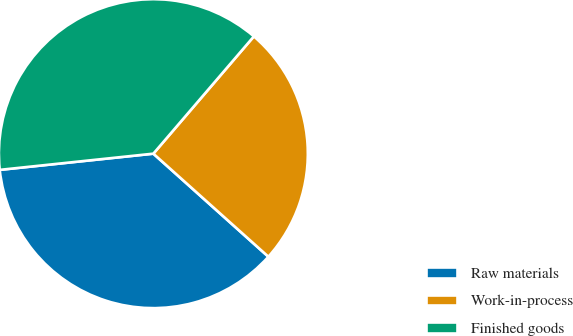Convert chart to OTSL. <chart><loc_0><loc_0><loc_500><loc_500><pie_chart><fcel>Raw materials<fcel>Work-in-process<fcel>Finished goods<nl><fcel>36.7%<fcel>25.35%<fcel>37.95%<nl></chart> 